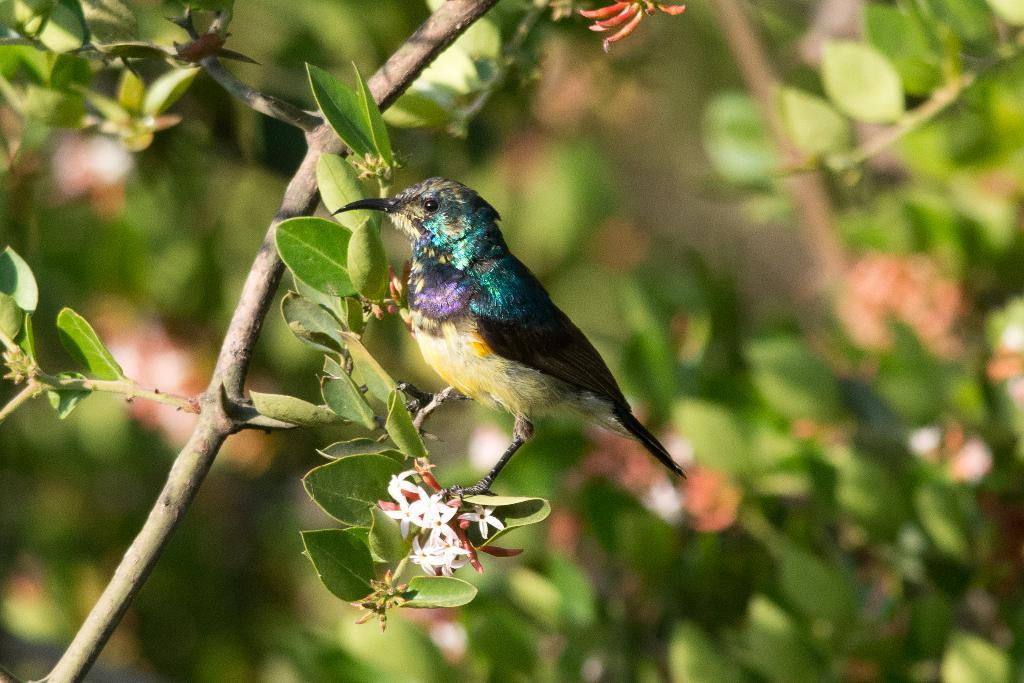What is the main subject in the middle of the image? There is a bird standing on the tree stem in the image. Where is the bird located in relation to the tree? The bird is on the tree stem. What type of flowers can be seen in the image? There are white flowers in the image. What can be seen in the background of the image? There are trees in the background of the image. How many children are playing with a key near the bird in the image? There are no children or keys present in the image; it features a bird on a tree stem with white flowers and trees in the background. 